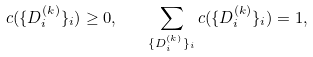<formula> <loc_0><loc_0><loc_500><loc_500>c ( \{ D _ { i } ^ { ( k ) } \} _ { i } ) \geq 0 , \quad \sum _ { \{ D _ { i } ^ { ( k ) } \} _ { i } } c ( \{ D _ { i } ^ { ( k ) } \} _ { i } ) = 1 ,</formula> 